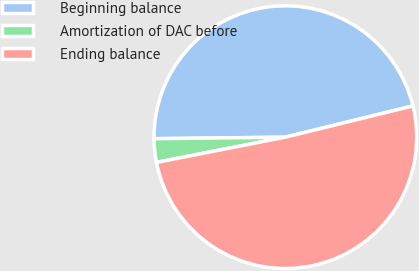Convert chart. <chart><loc_0><loc_0><loc_500><loc_500><pie_chart><fcel>Beginning balance<fcel>Amortization of DAC before<fcel>Ending balance<nl><fcel>46.36%<fcel>2.89%<fcel>50.75%<nl></chart> 